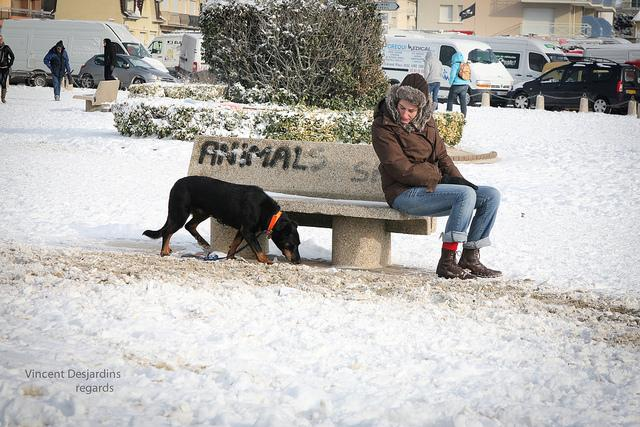What physical danger could she face if she was stuck in the cold with no winter apparel? Please explain your reasoning. frostbite. If the woman had no winter gear and was stuck in the cold, she could get not only frostbite, but also hypothermia. both conditions are very serious and are to be assiduously avoided. 